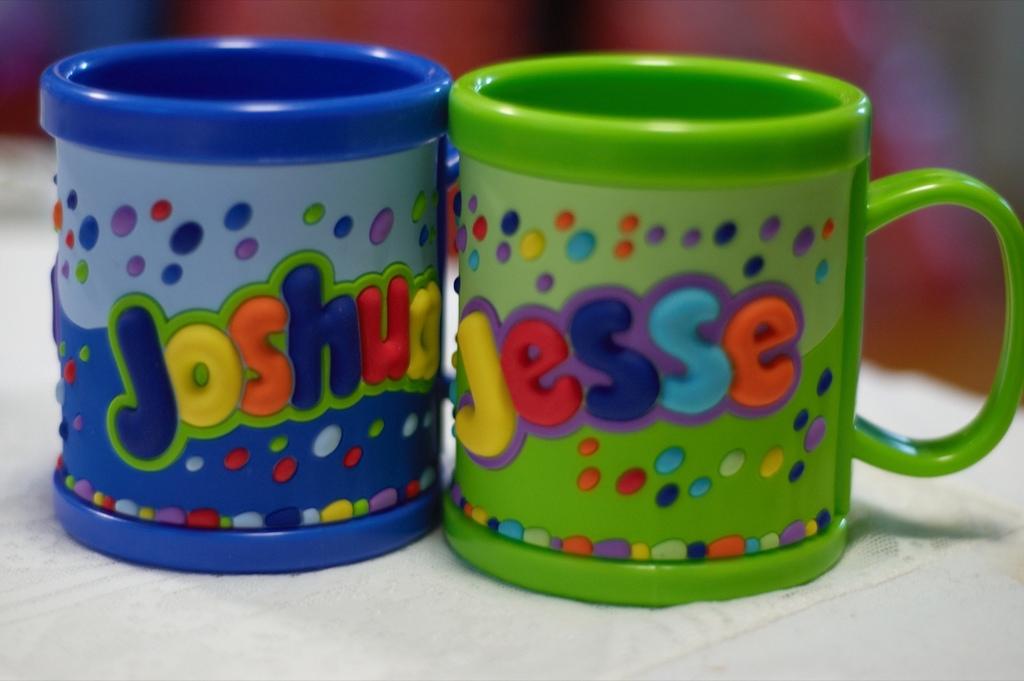Whose mug is the green mug for?
Your answer should be very brief. Jesse. Is joshua's mug the left one?
Ensure brevity in your answer.  Yes. 